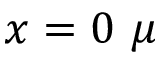<formula> <loc_0><loc_0><loc_500><loc_500>x = 0 \mu</formula> 